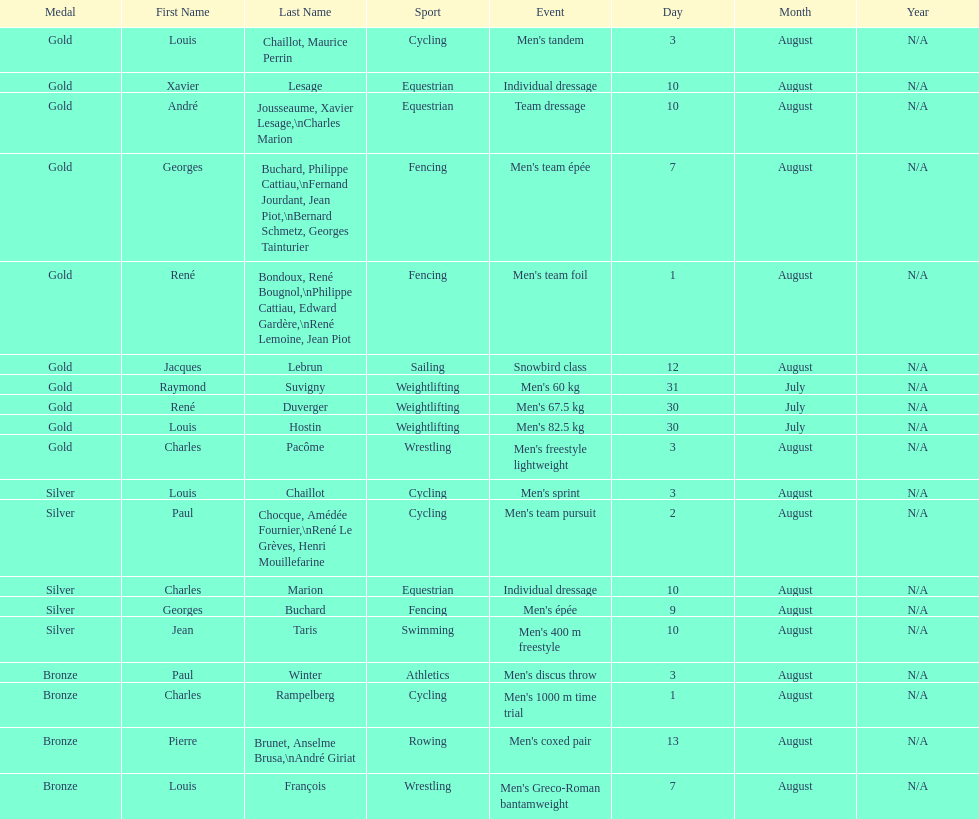Which event won the most medals? Cycling. 